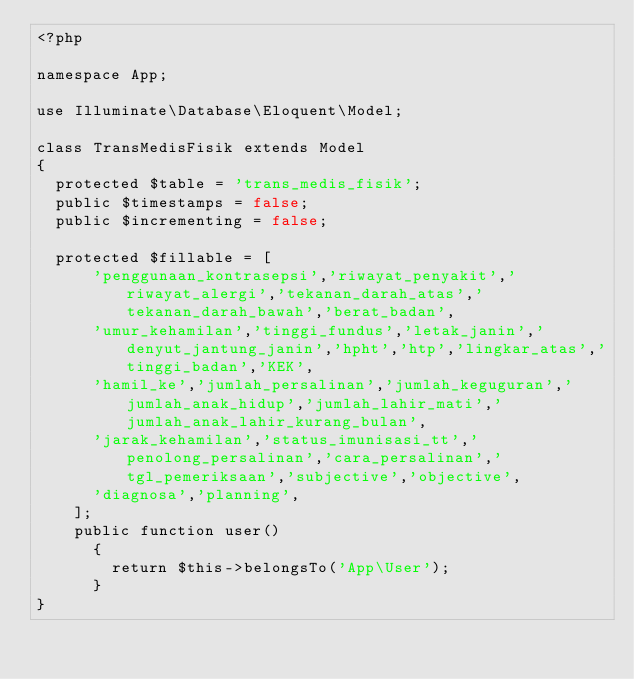Convert code to text. <code><loc_0><loc_0><loc_500><loc_500><_PHP_><?php

namespace App;

use Illuminate\Database\Eloquent\Model;

class TransMedisFisik extends Model
{
  protected $table = 'trans_medis_fisik';
  public $timestamps = false;
  public $incrementing = false;

  protected $fillable = [
      'penggunaan_kontrasepsi','riwayat_penyakit','riwayat_alergi','tekanan_darah_atas','tekanan_darah_bawah','berat_badan',
      'umur_kehamilan','tinggi_fundus','letak_janin','denyut_jantung_janin','hpht','htp','lingkar_atas','tinggi_badan','KEK',
      'hamil_ke','jumlah_persalinan','jumlah_keguguran','jumlah_anak_hidup','jumlah_lahir_mati','jumlah_anak_lahir_kurang_bulan',
      'jarak_kehamilan','status_imunisasi_tt','penolong_persalinan','cara_persalinan','tgl_pemeriksaan','subjective','objective',
      'diagnosa','planning',
    ];
    public function user()
      {
        return $this->belongsTo('App\User');
      }
}
</code> 